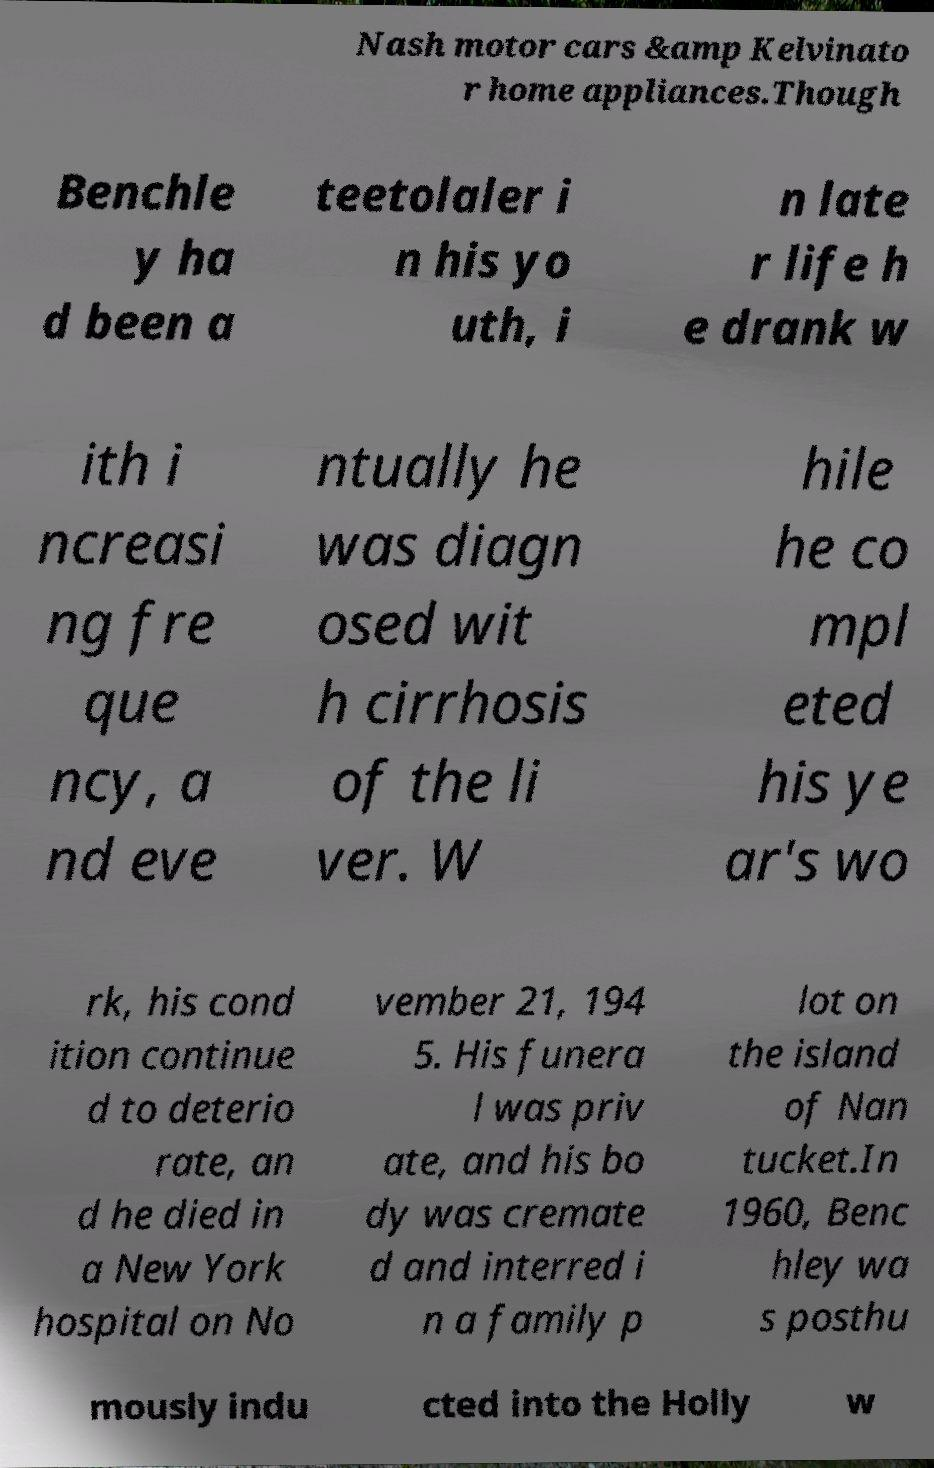Please read and relay the text visible in this image. What does it say? Nash motor cars &amp Kelvinato r home appliances.Though Benchle y ha d been a teetolaler i n his yo uth, i n late r life h e drank w ith i ncreasi ng fre que ncy, a nd eve ntually he was diagn osed wit h cirrhosis of the li ver. W hile he co mpl eted his ye ar's wo rk, his cond ition continue d to deterio rate, an d he died in a New York hospital on No vember 21, 194 5. His funera l was priv ate, and his bo dy was cremate d and interred i n a family p lot on the island of Nan tucket.In 1960, Benc hley wa s posthu mously indu cted into the Holly w 